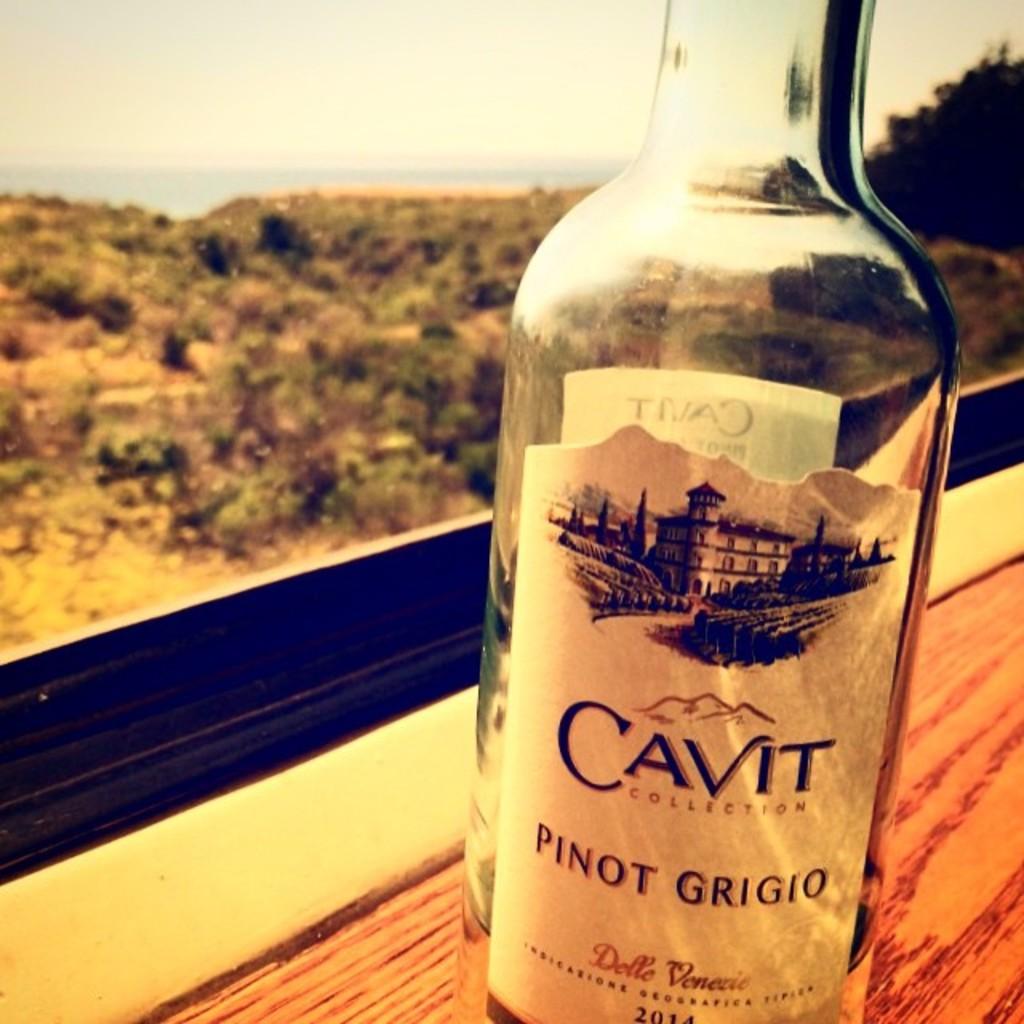What kind of wine is this?
Your answer should be compact. Pinot grigio. 